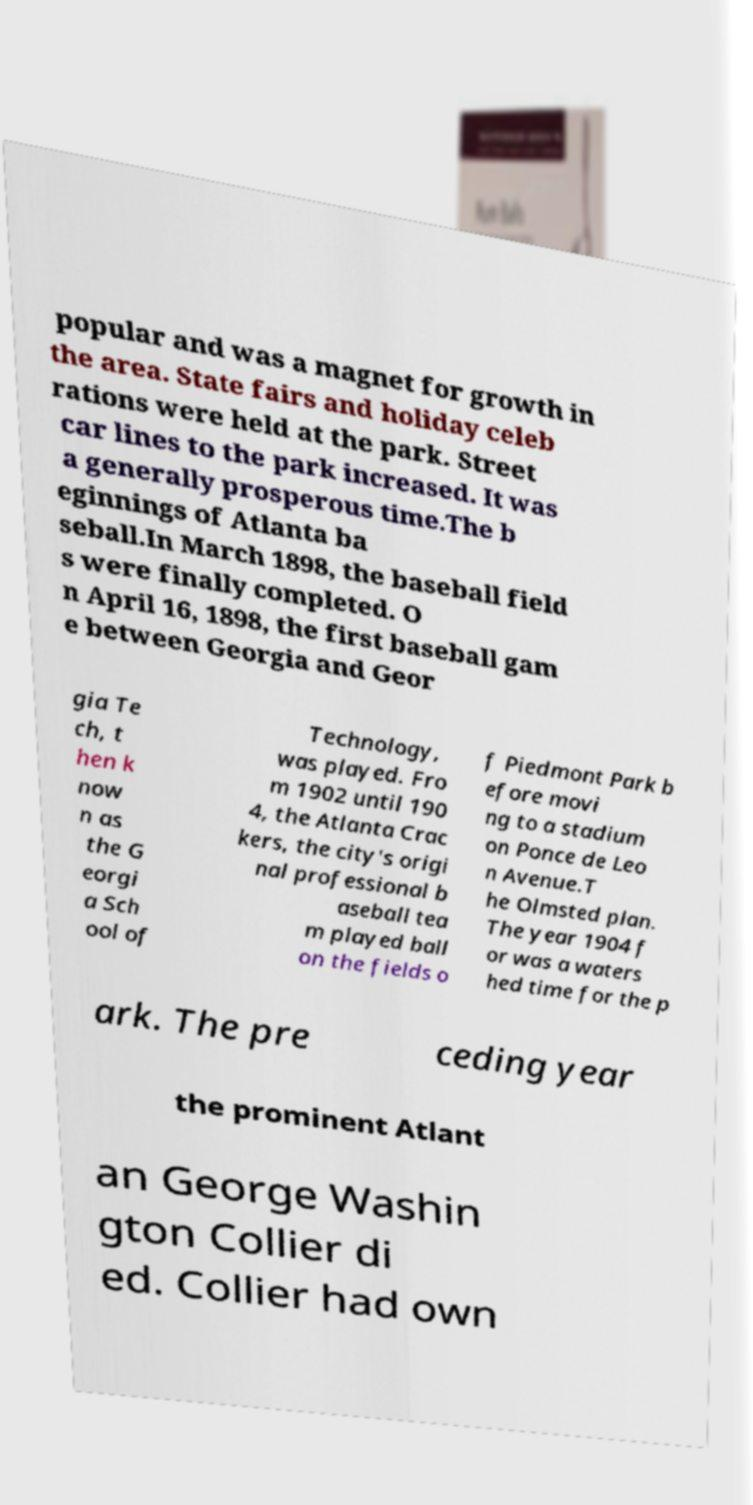For documentation purposes, I need the text within this image transcribed. Could you provide that? popular and was a magnet for growth in the area. State fairs and holiday celeb rations were held at the park. Street car lines to the park increased. It was a generally prosperous time.The b eginnings of Atlanta ba seball.In March 1898, the baseball field s were finally completed. O n April 16, 1898, the first baseball gam e between Georgia and Geor gia Te ch, t hen k now n as the G eorgi a Sch ool of Technology, was played. Fro m 1902 until 190 4, the Atlanta Crac kers, the city's origi nal professional b aseball tea m played ball on the fields o f Piedmont Park b efore movi ng to a stadium on Ponce de Leo n Avenue.T he Olmsted plan. The year 1904 f or was a waters hed time for the p ark. The pre ceding year the prominent Atlant an George Washin gton Collier di ed. Collier had own 